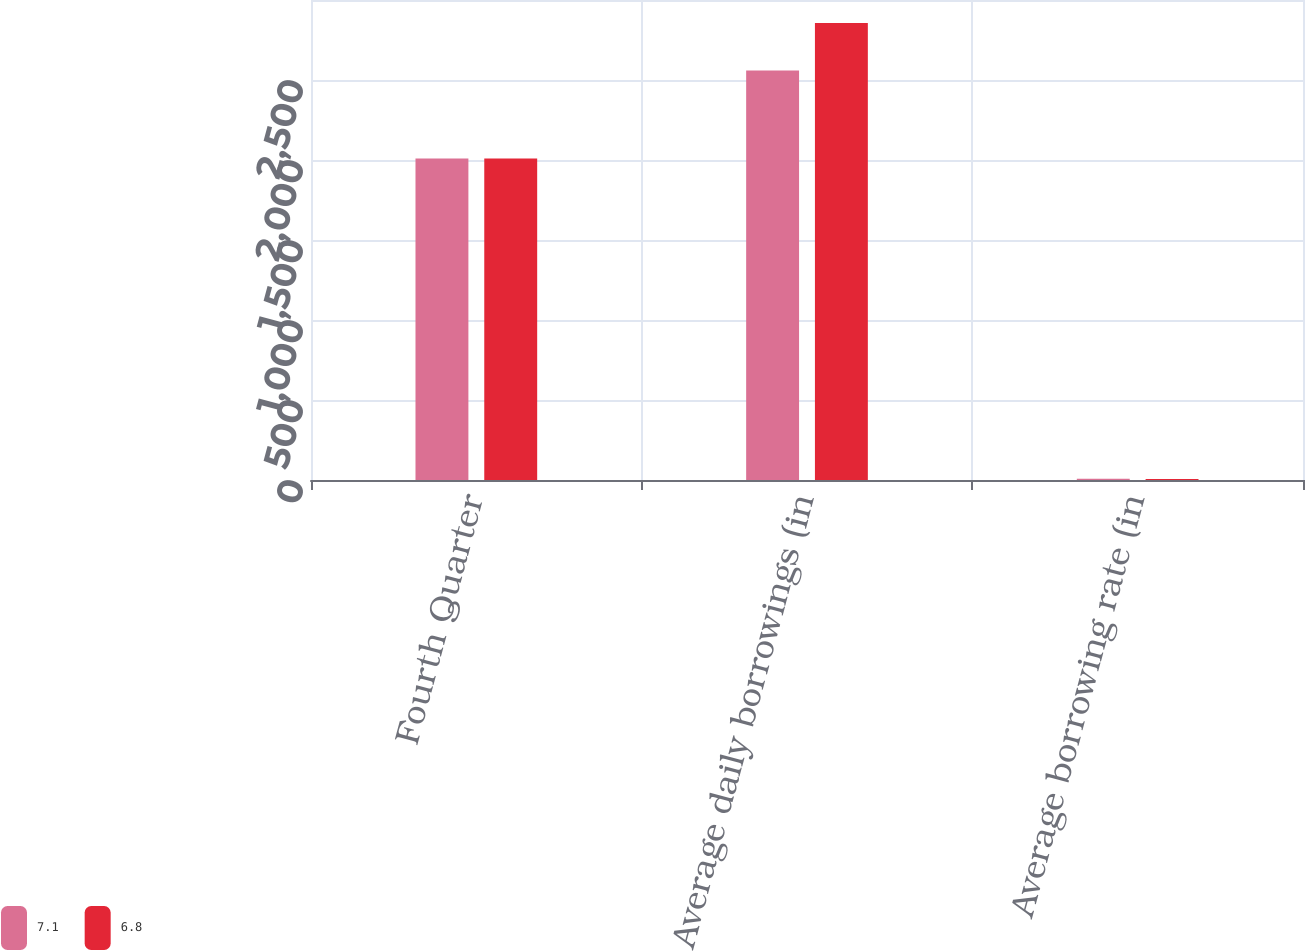Convert chart to OTSL. <chart><loc_0><loc_0><loc_500><loc_500><stacked_bar_chart><ecel><fcel>Fourth Quarter<fcel>Average daily borrowings (in<fcel>Average borrowing rate (in<nl><fcel>7.1<fcel>2010<fcel>2560<fcel>7.1<nl><fcel>6.8<fcel>2009<fcel>2857<fcel>6.8<nl></chart> 